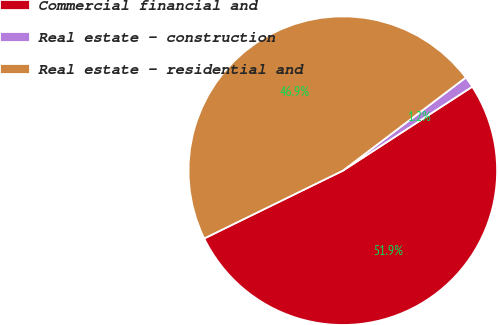Convert chart. <chart><loc_0><loc_0><loc_500><loc_500><pie_chart><fcel>Commercial financial and<fcel>Real estate - construction<fcel>Real estate - residential and<nl><fcel>51.92%<fcel>1.16%<fcel>46.92%<nl></chart> 